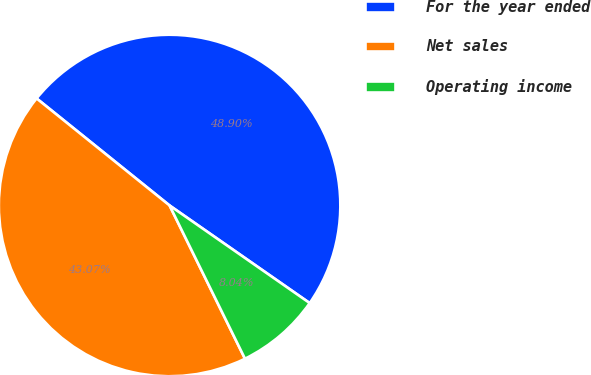<chart> <loc_0><loc_0><loc_500><loc_500><pie_chart><fcel>For the year ended<fcel>Net sales<fcel>Operating income<nl><fcel>48.9%<fcel>43.07%<fcel>8.04%<nl></chart> 